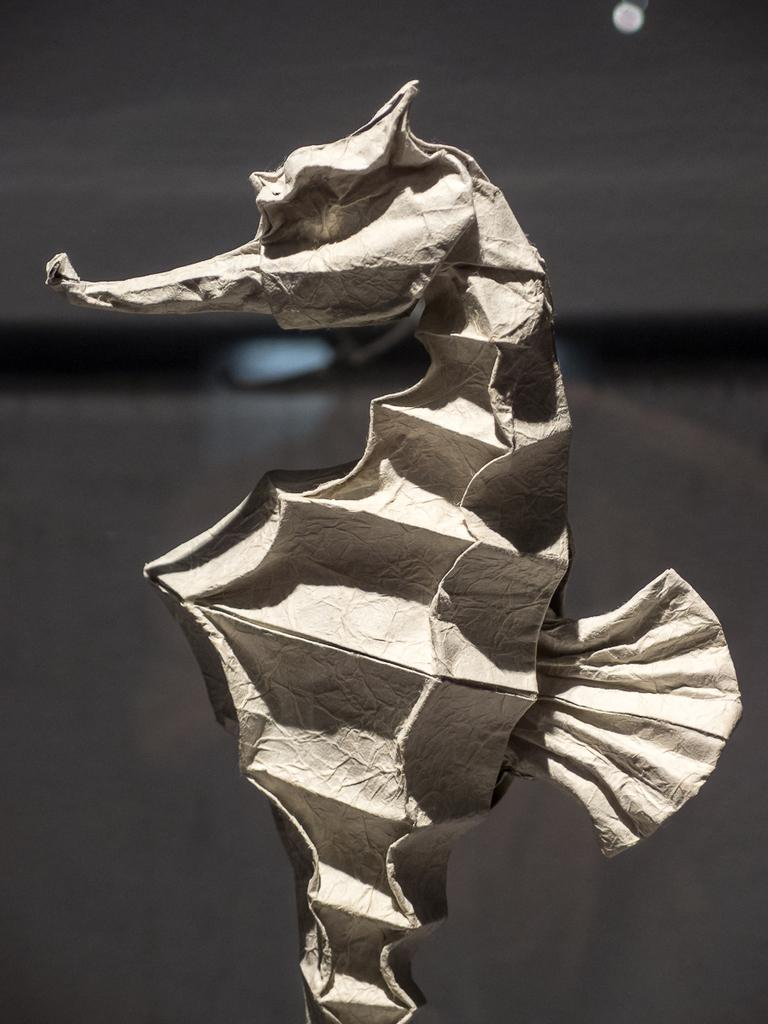What is the main subject of the image? The main subject of the image is a seahorse. What material is the seahorse made of? The seahorse is made with paper. What type of bait is the seahorse using to catch fish in the image? There is no indication in the image that the seahorse is trying to catch fish or using bait. 